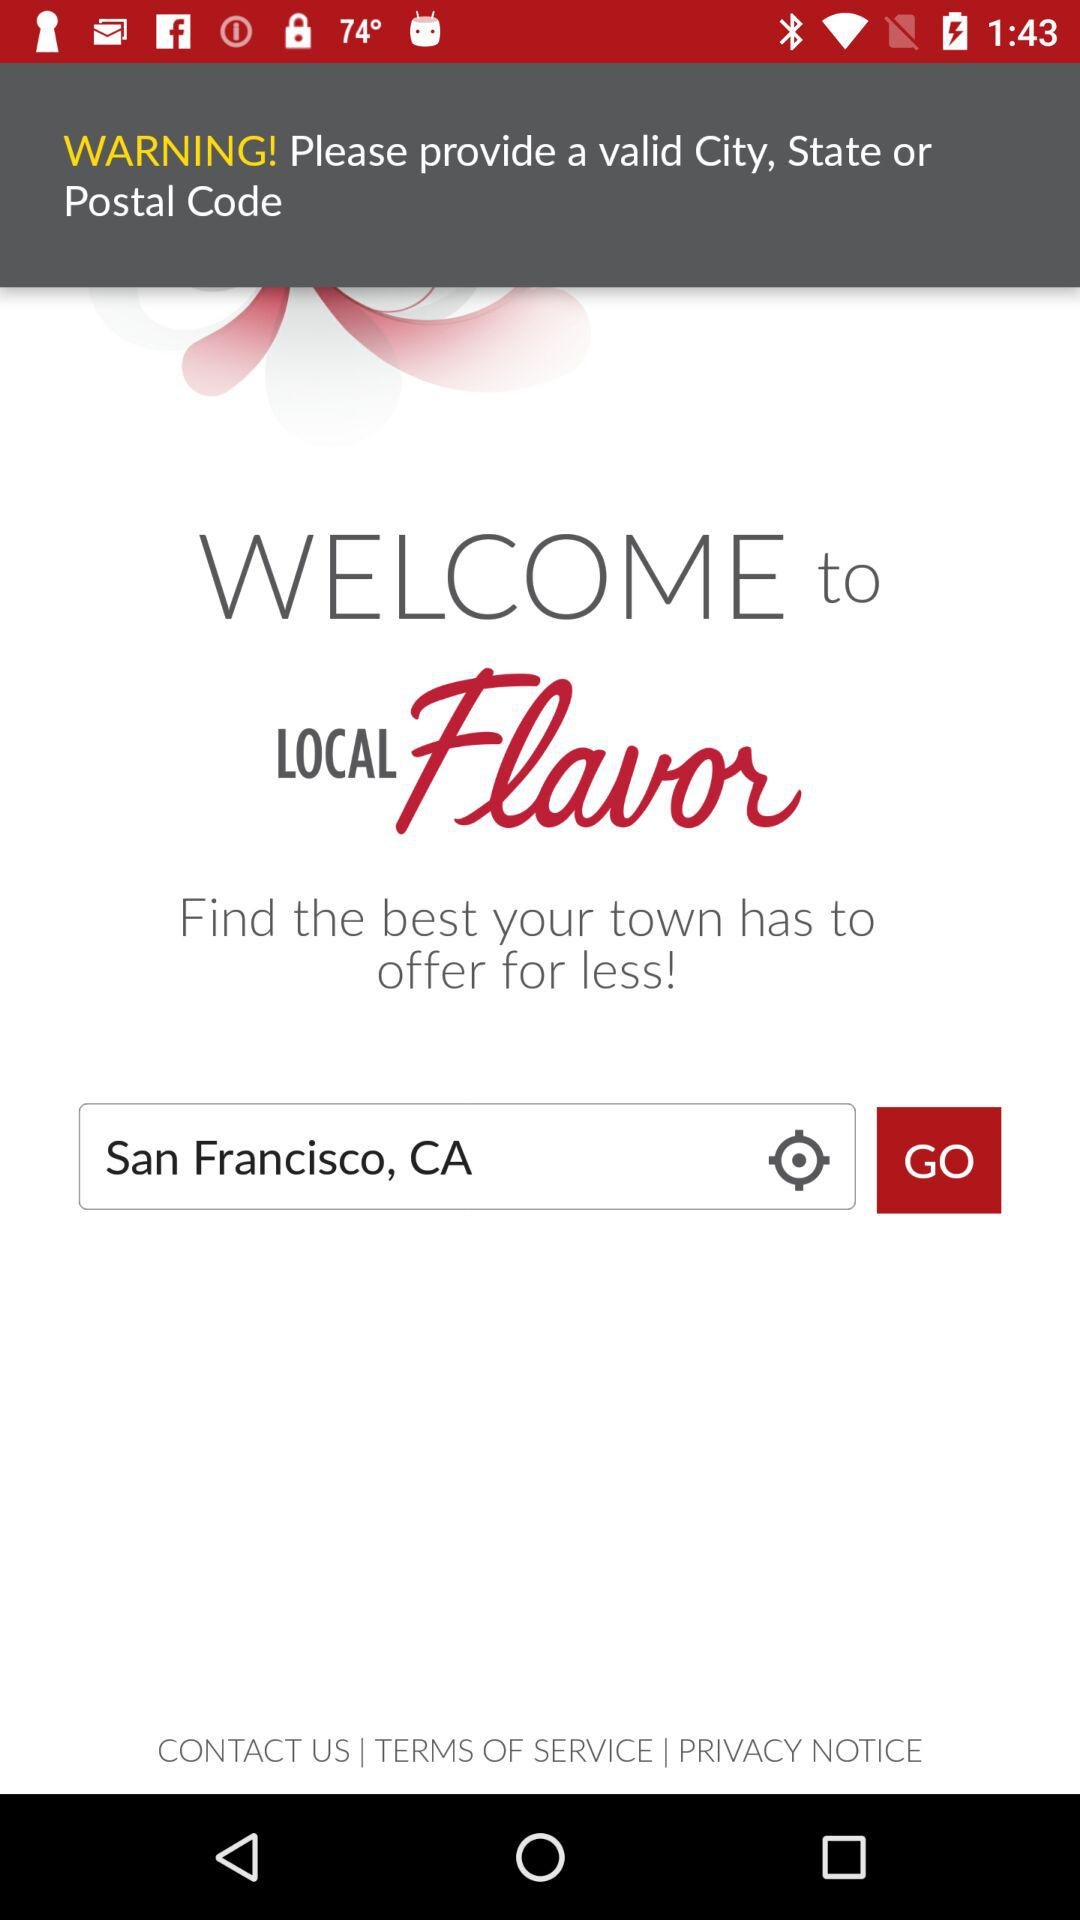What is the selected location? The selected location is San Francisco, CA. 